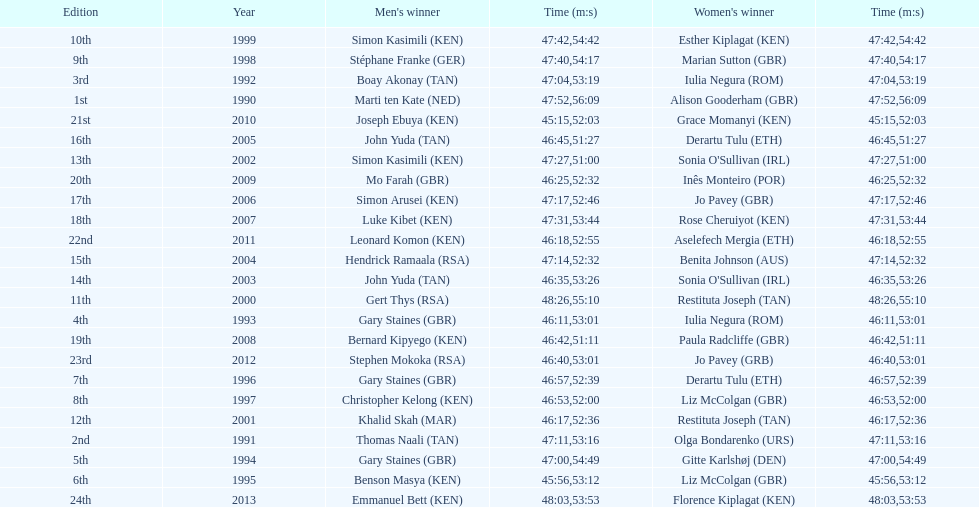Number of men's winners with a finish time under 46:58 12. 